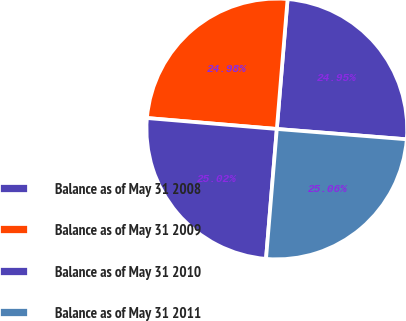<chart> <loc_0><loc_0><loc_500><loc_500><pie_chart><fcel>Balance as of May 31 2008<fcel>Balance as of May 31 2009<fcel>Balance as of May 31 2010<fcel>Balance as of May 31 2011<nl><fcel>24.95%<fcel>24.98%<fcel>25.02%<fcel>25.06%<nl></chart> 